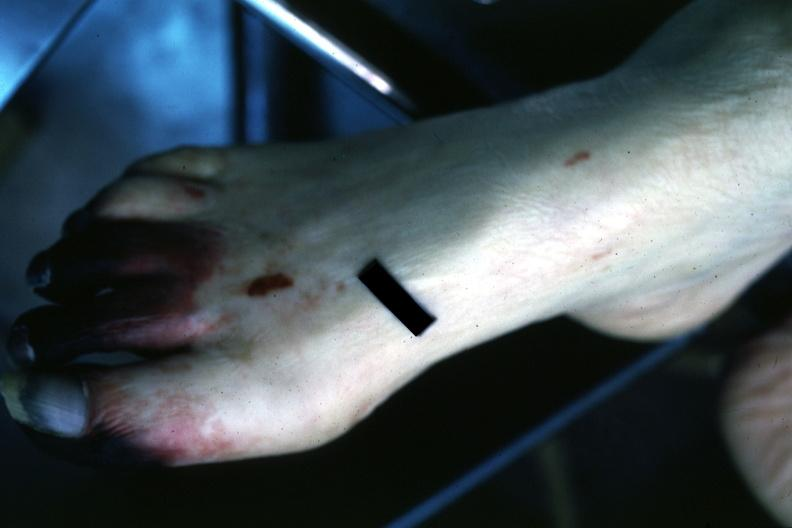re six digits and syndactyly present?
Answer the question using a single word or phrase. No 